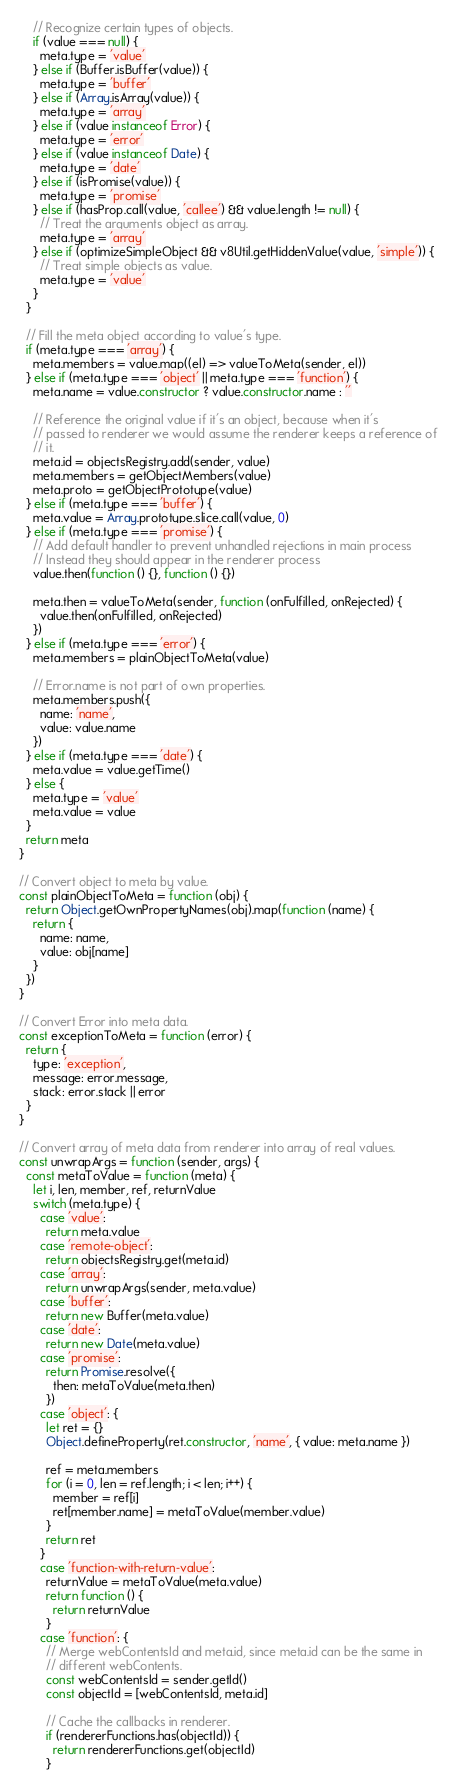Convert code to text. <code><loc_0><loc_0><loc_500><loc_500><_JavaScript_>    // Recognize certain types of objects.
    if (value === null) {
      meta.type = 'value'
    } else if (Buffer.isBuffer(value)) {
      meta.type = 'buffer'
    } else if (Array.isArray(value)) {
      meta.type = 'array'
    } else if (value instanceof Error) {
      meta.type = 'error'
    } else if (value instanceof Date) {
      meta.type = 'date'
    } else if (isPromise(value)) {
      meta.type = 'promise'
    } else if (hasProp.call(value, 'callee') && value.length != null) {
      // Treat the arguments object as array.
      meta.type = 'array'
    } else if (optimizeSimpleObject && v8Util.getHiddenValue(value, 'simple')) {
      // Treat simple objects as value.
      meta.type = 'value'
    }
  }

  // Fill the meta object according to value's type.
  if (meta.type === 'array') {
    meta.members = value.map((el) => valueToMeta(sender, el))
  } else if (meta.type === 'object' || meta.type === 'function') {
    meta.name = value.constructor ? value.constructor.name : ''

    // Reference the original value if it's an object, because when it's
    // passed to renderer we would assume the renderer keeps a reference of
    // it.
    meta.id = objectsRegistry.add(sender, value)
    meta.members = getObjectMembers(value)
    meta.proto = getObjectPrototype(value)
  } else if (meta.type === 'buffer') {
    meta.value = Array.prototype.slice.call(value, 0)
  } else if (meta.type === 'promise') {
    // Add default handler to prevent unhandled rejections in main process
    // Instead they should appear in the renderer process
    value.then(function () {}, function () {})

    meta.then = valueToMeta(sender, function (onFulfilled, onRejected) {
      value.then(onFulfilled, onRejected)
    })
  } else if (meta.type === 'error') {
    meta.members = plainObjectToMeta(value)

    // Error.name is not part of own properties.
    meta.members.push({
      name: 'name',
      value: value.name
    })
  } else if (meta.type === 'date') {
    meta.value = value.getTime()
  } else {
    meta.type = 'value'
    meta.value = value
  }
  return meta
}

// Convert object to meta by value.
const plainObjectToMeta = function (obj) {
  return Object.getOwnPropertyNames(obj).map(function (name) {
    return {
      name: name,
      value: obj[name]
    }
  })
}

// Convert Error into meta data.
const exceptionToMeta = function (error) {
  return {
    type: 'exception',
    message: error.message,
    stack: error.stack || error
  }
}

// Convert array of meta data from renderer into array of real values.
const unwrapArgs = function (sender, args) {
  const metaToValue = function (meta) {
    let i, len, member, ref, returnValue
    switch (meta.type) {
      case 'value':
        return meta.value
      case 'remote-object':
        return objectsRegistry.get(meta.id)
      case 'array':
        return unwrapArgs(sender, meta.value)
      case 'buffer':
        return new Buffer(meta.value)
      case 'date':
        return new Date(meta.value)
      case 'promise':
        return Promise.resolve({
          then: metaToValue(meta.then)
        })
      case 'object': {
        let ret = {}
        Object.defineProperty(ret.constructor, 'name', { value: meta.name })

        ref = meta.members
        for (i = 0, len = ref.length; i < len; i++) {
          member = ref[i]
          ret[member.name] = metaToValue(member.value)
        }
        return ret
      }
      case 'function-with-return-value':
        returnValue = metaToValue(meta.value)
        return function () {
          return returnValue
        }
      case 'function': {
        // Merge webContentsId and meta.id, since meta.id can be the same in
        // different webContents.
        const webContentsId = sender.getId()
        const objectId = [webContentsId, meta.id]

        // Cache the callbacks in renderer.
        if (rendererFunctions.has(objectId)) {
          return rendererFunctions.get(objectId)
        }
</code> 